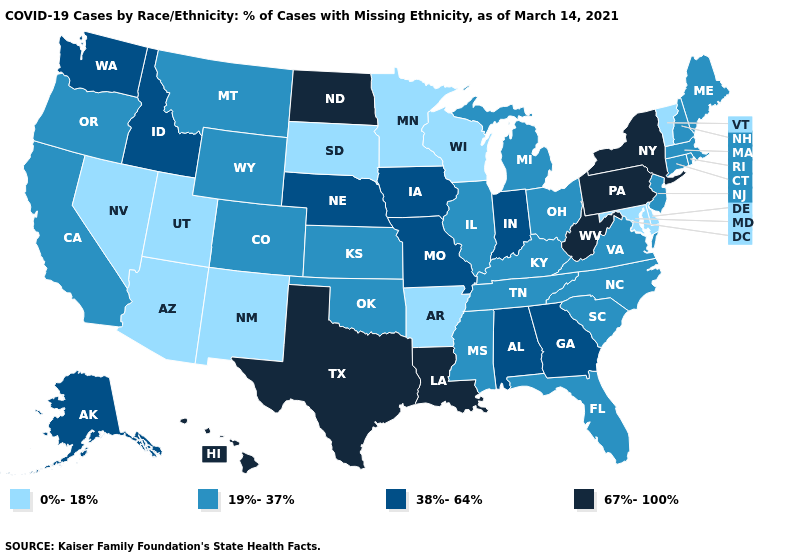Which states hav the highest value in the West?
Give a very brief answer. Hawaii. Name the states that have a value in the range 19%-37%?
Give a very brief answer. California, Colorado, Connecticut, Florida, Illinois, Kansas, Kentucky, Maine, Massachusetts, Michigan, Mississippi, Montana, New Hampshire, New Jersey, North Carolina, Ohio, Oklahoma, Oregon, Rhode Island, South Carolina, Tennessee, Virginia, Wyoming. Name the states that have a value in the range 0%-18%?
Quick response, please. Arizona, Arkansas, Delaware, Maryland, Minnesota, Nevada, New Mexico, South Dakota, Utah, Vermont, Wisconsin. Among the states that border North Carolina , which have the highest value?
Quick response, please. Georgia. Which states hav the highest value in the West?
Write a very short answer. Hawaii. What is the lowest value in states that border Virginia?
Write a very short answer. 0%-18%. Does the first symbol in the legend represent the smallest category?
Quick response, please. Yes. Among the states that border Ohio , does Kentucky have the highest value?
Give a very brief answer. No. Does the first symbol in the legend represent the smallest category?
Write a very short answer. Yes. What is the value of Connecticut?
Concise answer only. 19%-37%. What is the lowest value in the USA?
Keep it brief. 0%-18%. What is the highest value in the USA?
Write a very short answer. 67%-100%. Is the legend a continuous bar?
Quick response, please. No. What is the value of Hawaii?
Keep it brief. 67%-100%. Name the states that have a value in the range 38%-64%?
Keep it brief. Alabama, Alaska, Georgia, Idaho, Indiana, Iowa, Missouri, Nebraska, Washington. 